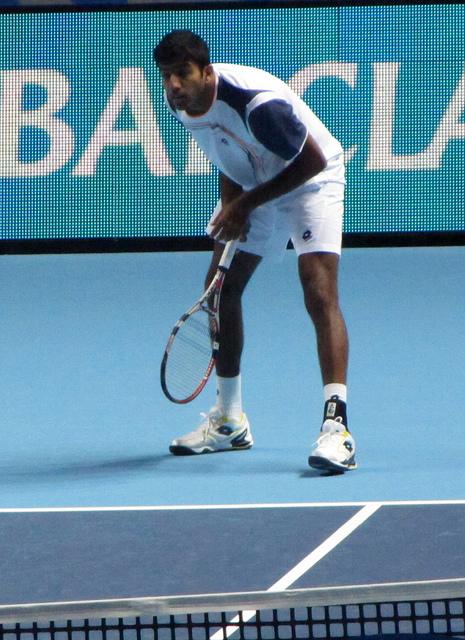What sport are they playing?
Quick response, please. Tennis. What does the man have on his head?
Quick response, please. Hair. Why is the man holding the racket?
Concise answer only. Playing tennis. 